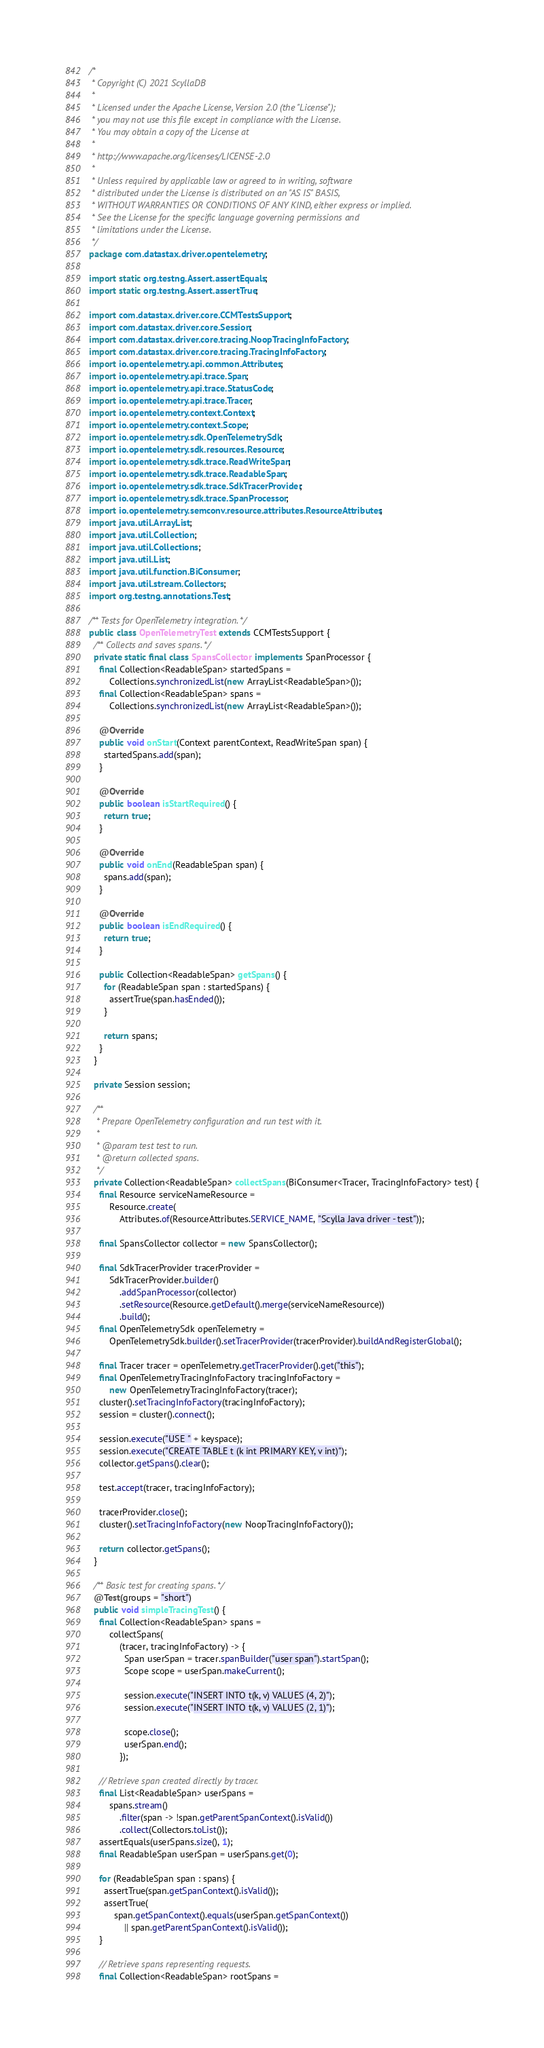Convert code to text. <code><loc_0><loc_0><loc_500><loc_500><_Java_>/*
 * Copyright (C) 2021 ScyllaDB
 *
 * Licensed under the Apache License, Version 2.0 (the "License");
 * you may not use this file except in compliance with the License.
 * You may obtain a copy of the License at
 *
 * http://www.apache.org/licenses/LICENSE-2.0
 *
 * Unless required by applicable law or agreed to in writing, software
 * distributed under the License is distributed on an "AS IS" BASIS,
 * WITHOUT WARRANTIES OR CONDITIONS OF ANY KIND, either express or implied.
 * See the License for the specific language governing permissions and
 * limitations under the License.
 */
package com.datastax.driver.opentelemetry;

import static org.testng.Assert.assertEquals;
import static org.testng.Assert.assertTrue;

import com.datastax.driver.core.CCMTestsSupport;
import com.datastax.driver.core.Session;
import com.datastax.driver.core.tracing.NoopTracingInfoFactory;
import com.datastax.driver.core.tracing.TracingInfoFactory;
import io.opentelemetry.api.common.Attributes;
import io.opentelemetry.api.trace.Span;
import io.opentelemetry.api.trace.StatusCode;
import io.opentelemetry.api.trace.Tracer;
import io.opentelemetry.context.Context;
import io.opentelemetry.context.Scope;
import io.opentelemetry.sdk.OpenTelemetrySdk;
import io.opentelemetry.sdk.resources.Resource;
import io.opentelemetry.sdk.trace.ReadWriteSpan;
import io.opentelemetry.sdk.trace.ReadableSpan;
import io.opentelemetry.sdk.trace.SdkTracerProvider;
import io.opentelemetry.sdk.trace.SpanProcessor;
import io.opentelemetry.semconv.resource.attributes.ResourceAttributes;
import java.util.ArrayList;
import java.util.Collection;
import java.util.Collections;
import java.util.List;
import java.util.function.BiConsumer;
import java.util.stream.Collectors;
import org.testng.annotations.Test;

/** Tests for OpenTelemetry integration. */
public class OpenTelemetryTest extends CCMTestsSupport {
  /** Collects and saves spans. */
  private static final class SpansCollector implements SpanProcessor {
    final Collection<ReadableSpan> startedSpans =
        Collections.synchronizedList(new ArrayList<ReadableSpan>());
    final Collection<ReadableSpan> spans =
        Collections.synchronizedList(new ArrayList<ReadableSpan>());

    @Override
    public void onStart(Context parentContext, ReadWriteSpan span) {
      startedSpans.add(span);
    }

    @Override
    public boolean isStartRequired() {
      return true;
    }

    @Override
    public void onEnd(ReadableSpan span) {
      spans.add(span);
    }

    @Override
    public boolean isEndRequired() {
      return true;
    }

    public Collection<ReadableSpan> getSpans() {
      for (ReadableSpan span : startedSpans) {
        assertTrue(span.hasEnded());
      }

      return spans;
    }
  }

  private Session session;

  /**
   * Prepare OpenTelemetry configuration and run test with it.
   *
   * @param test test to run.
   * @return collected spans.
   */
  private Collection<ReadableSpan> collectSpans(BiConsumer<Tracer, TracingInfoFactory> test) {
    final Resource serviceNameResource =
        Resource.create(
            Attributes.of(ResourceAttributes.SERVICE_NAME, "Scylla Java driver - test"));

    final SpansCollector collector = new SpansCollector();

    final SdkTracerProvider tracerProvider =
        SdkTracerProvider.builder()
            .addSpanProcessor(collector)
            .setResource(Resource.getDefault().merge(serviceNameResource))
            .build();
    final OpenTelemetrySdk openTelemetry =
        OpenTelemetrySdk.builder().setTracerProvider(tracerProvider).buildAndRegisterGlobal();

    final Tracer tracer = openTelemetry.getTracerProvider().get("this");
    final OpenTelemetryTracingInfoFactory tracingInfoFactory =
        new OpenTelemetryTracingInfoFactory(tracer);
    cluster().setTracingInfoFactory(tracingInfoFactory);
    session = cluster().connect();

    session.execute("USE " + keyspace);
    session.execute("CREATE TABLE t (k int PRIMARY KEY, v int)");
    collector.getSpans().clear();

    test.accept(tracer, tracingInfoFactory);

    tracerProvider.close();
    cluster().setTracingInfoFactory(new NoopTracingInfoFactory());

    return collector.getSpans();
  }

  /** Basic test for creating spans. */
  @Test(groups = "short")
  public void simpleTracingTest() {
    final Collection<ReadableSpan> spans =
        collectSpans(
            (tracer, tracingInfoFactory) -> {
              Span userSpan = tracer.spanBuilder("user span").startSpan();
              Scope scope = userSpan.makeCurrent();

              session.execute("INSERT INTO t(k, v) VALUES (4, 2)");
              session.execute("INSERT INTO t(k, v) VALUES (2, 1)");

              scope.close();
              userSpan.end();
            });

    // Retrieve span created directly by tracer.
    final List<ReadableSpan> userSpans =
        spans.stream()
            .filter(span -> !span.getParentSpanContext().isValid())
            .collect(Collectors.toList());
    assertEquals(userSpans.size(), 1);
    final ReadableSpan userSpan = userSpans.get(0);

    for (ReadableSpan span : spans) {
      assertTrue(span.getSpanContext().isValid());
      assertTrue(
          span.getSpanContext().equals(userSpan.getSpanContext())
              || span.getParentSpanContext().isValid());
    }

    // Retrieve spans representing requests.
    final Collection<ReadableSpan> rootSpans =</code> 